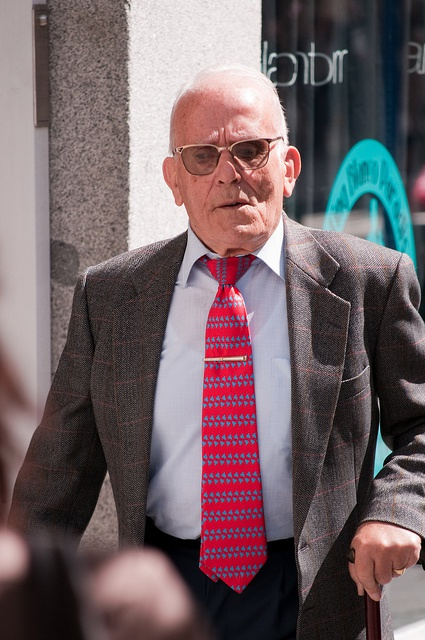Describe the objects in this image and their specific colors. I can see people in darkgray, black, gray, and brown tones and tie in darkgray, brown, and gray tones in this image. 